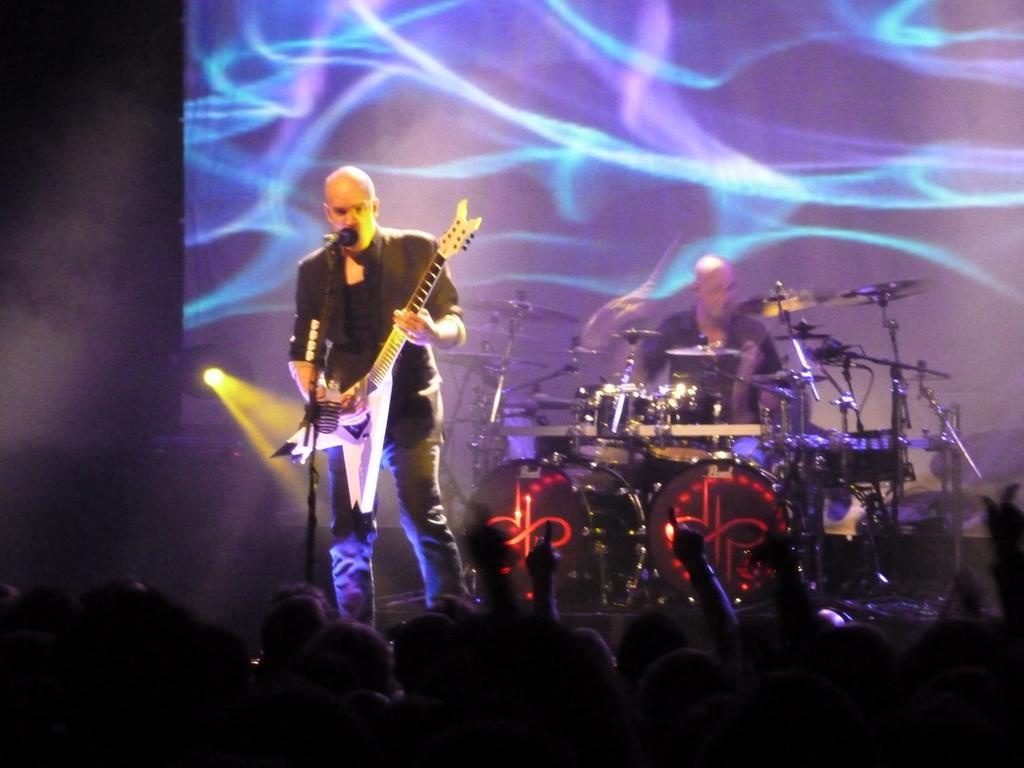Could you give a brief overview of what you see in this image? Here I can see a man standing on the stage and playing a guitar. In front of this man there is a mike stand. In the background there is another person playing the drums. At the bottom, I can see a crowd of people in the dark. In the background there is a screen. 